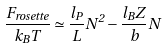<formula> <loc_0><loc_0><loc_500><loc_500>\frac { F _ { r o s e t t e } } { k _ { B } T } \simeq \frac { l _ { P } } { L } N ^ { 2 } - \frac { l _ { B } Z } { b } N</formula> 